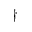<formula> <loc_0><loc_0><loc_500><loc_500>^ { \dagger }</formula> 